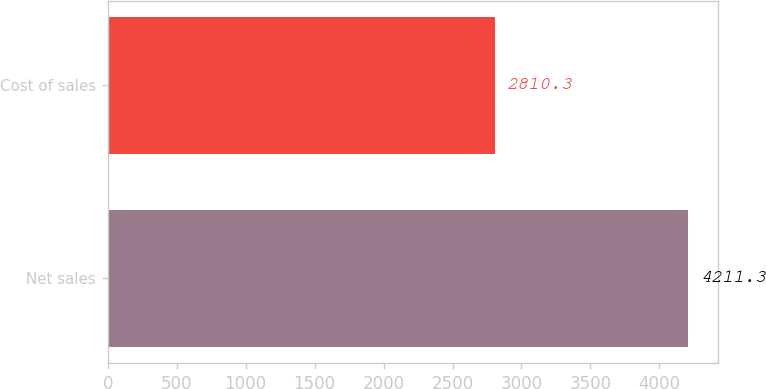Convert chart to OTSL. <chart><loc_0><loc_0><loc_500><loc_500><bar_chart><fcel>Net sales<fcel>Cost of sales<nl><fcel>4211.3<fcel>2810.3<nl></chart> 